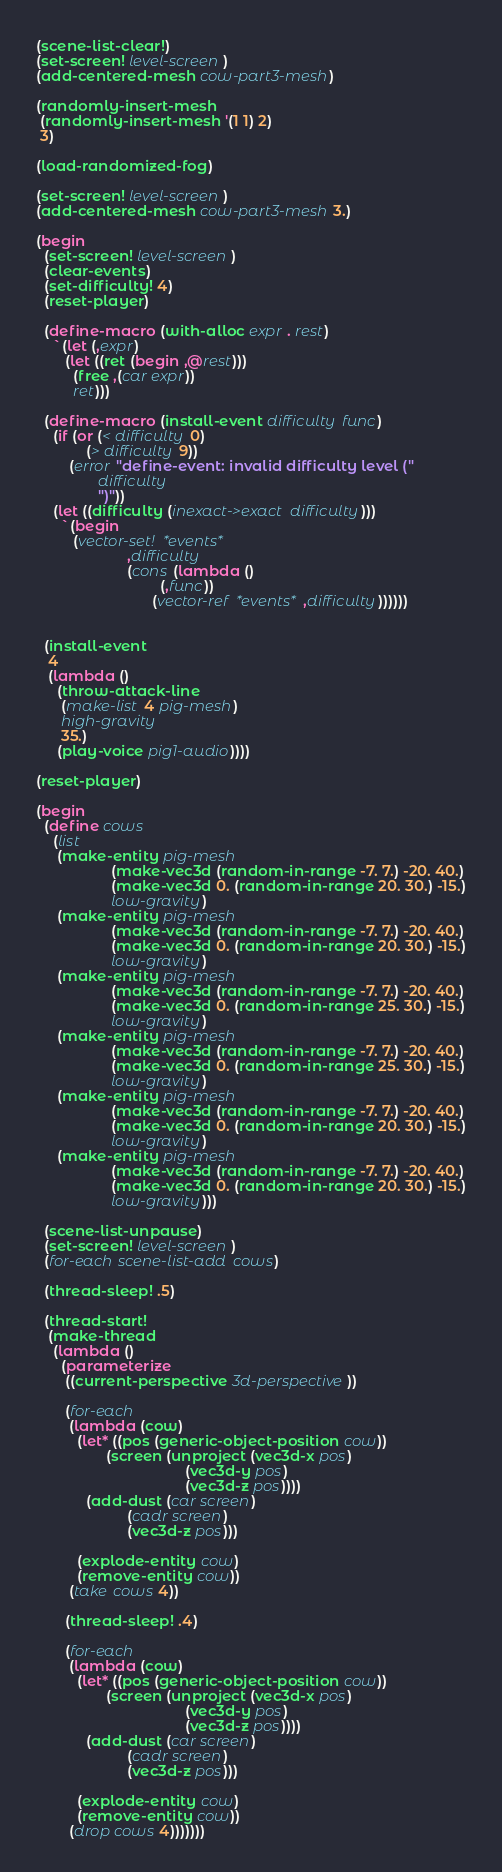<code> <loc_0><loc_0><loc_500><loc_500><_Scheme_>
(scene-list-clear!)
(set-screen! level-screen)
(add-centered-mesh cow-part3-mesh)

(randomly-insert-mesh 
 (randomly-insert-mesh '(1 1) 2)
 3)

(load-randomized-fog)

(set-screen! level-screen)
(add-centered-mesh cow-part3-mesh 3.)

(begin
  (set-screen! level-screen)
  (clear-events)
  (set-difficulty! 4)
  (reset-player)
  
  (define-macro (with-alloc expr . rest)
    `(let (,expr)
       (let ((ret (begin ,@rest)))
         (free ,(car expr))
         ret)))
  
  (define-macro (install-event difficulty func)
    (if (or (< difficulty 0)
            (> difficulty 9))
        (error "define-event: invalid difficulty level ("
               difficulty
               ")"))
    (let ((difficulty (inexact->exact difficulty)))
      `(begin
         (vector-set! *events*
                      ,difficulty
                      (cons (lambda ()
                              (,func))
                            (vector-ref *events* ,difficulty))))))
  

  (install-event
   4
   (lambda ()
     (throw-attack-line
      (make-list 4 pig-mesh)
      high-gravity
      35.)
     (play-voice pig1-audio))))

(reset-player)

(begin
  (define cows
    (list
     (make-entity pig-mesh
                  (make-vec3d (random-in-range -7. 7.) -20. 40.)
                  (make-vec3d 0. (random-in-range 20. 30.) -15.)
                  low-gravity)
     (make-entity pig-mesh
                  (make-vec3d (random-in-range -7. 7.) -20. 40.)
                  (make-vec3d 0. (random-in-range 20. 30.) -15.)
                  low-gravity)
     (make-entity pig-mesh
                  (make-vec3d (random-in-range -7. 7.) -20. 40.)
                  (make-vec3d 0. (random-in-range 25. 30.) -15.)
                  low-gravity)
     (make-entity pig-mesh
                  (make-vec3d (random-in-range -7. 7.) -20. 40.)
                  (make-vec3d 0. (random-in-range 25. 30.) -15.)
                  low-gravity)
     (make-entity pig-mesh
                  (make-vec3d (random-in-range -7. 7.) -20. 40.)
                  (make-vec3d 0. (random-in-range 20. 30.) -15.)
                  low-gravity)
     (make-entity pig-mesh
                  (make-vec3d (random-in-range -7. 7.) -20. 40.)
                  (make-vec3d 0. (random-in-range 20. 30.) -15.)
                  low-gravity)))

  (scene-list-unpause)
  (set-screen! level-screen)
  (for-each scene-list-add cows)

  (thread-sleep! .5)
  
  (thread-start!
   (make-thread
    (lambda ()
      (parameterize
       ((current-perspective 3d-perspective))

       (for-each
        (lambda (cow)
          (let* ((pos (generic-object-position cow))
                 (screen (unproject (vec3d-x pos)
                                    (vec3d-y pos)
                                    (vec3d-z pos))))
            (add-dust (car screen)
                      (cadr screen)
                      (vec3d-z pos)))
          
          (explode-entity cow)
          (remove-entity cow))
        (take cows 4))

       (thread-sleep! .4)
       
       (for-each
        (lambda (cow)
          (let* ((pos (generic-object-position cow))
                 (screen (unproject (vec3d-x pos)
                                    (vec3d-y pos)
                                    (vec3d-z pos))))
            (add-dust (car screen)
                      (cadr screen)
                      (vec3d-z pos)))
          
          (explode-entity cow)
          (remove-entity cow))
        (drop cows 4)))))))
</code> 